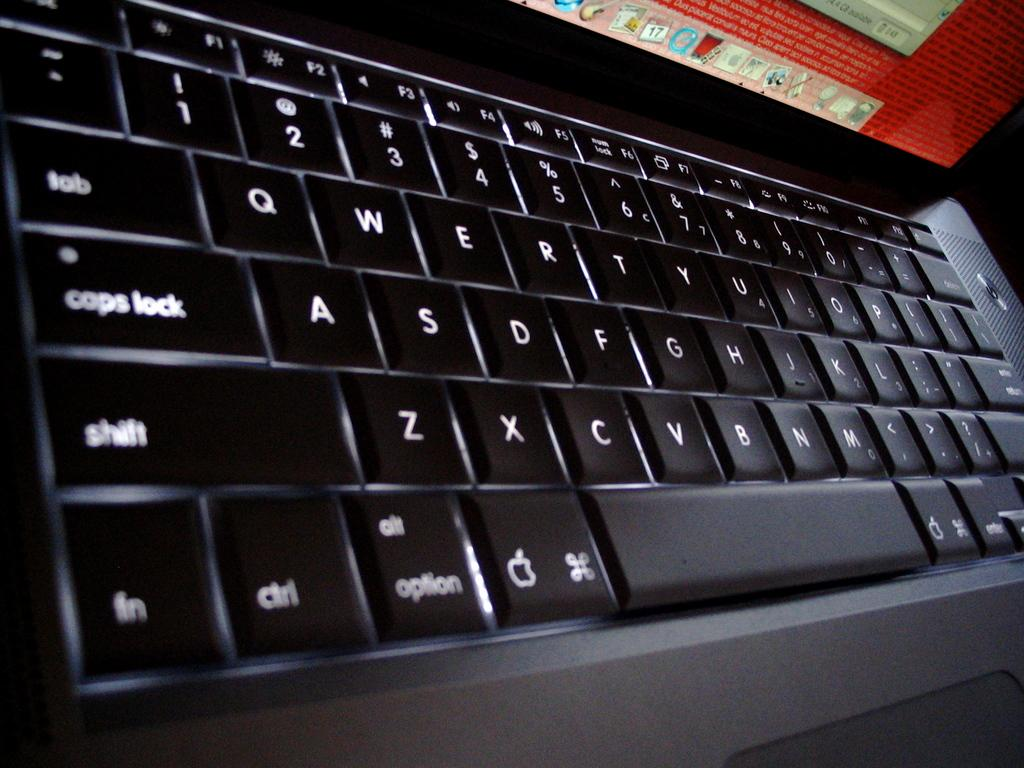What electronic device is present in the image? There is a laptop in the image. What part of the laptop is visible in the foreground? The keyboard of the laptop is visible in the foreground. What type of waste is visible on the laptop's screen in the image? There is no waste visible on the laptop's screen in the image. Is there a chain attached to the laptop in the image? There is no chain attached to the laptop in the image. 